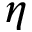<formula> <loc_0><loc_0><loc_500><loc_500>\eta</formula> 